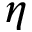<formula> <loc_0><loc_0><loc_500><loc_500>\eta</formula> 